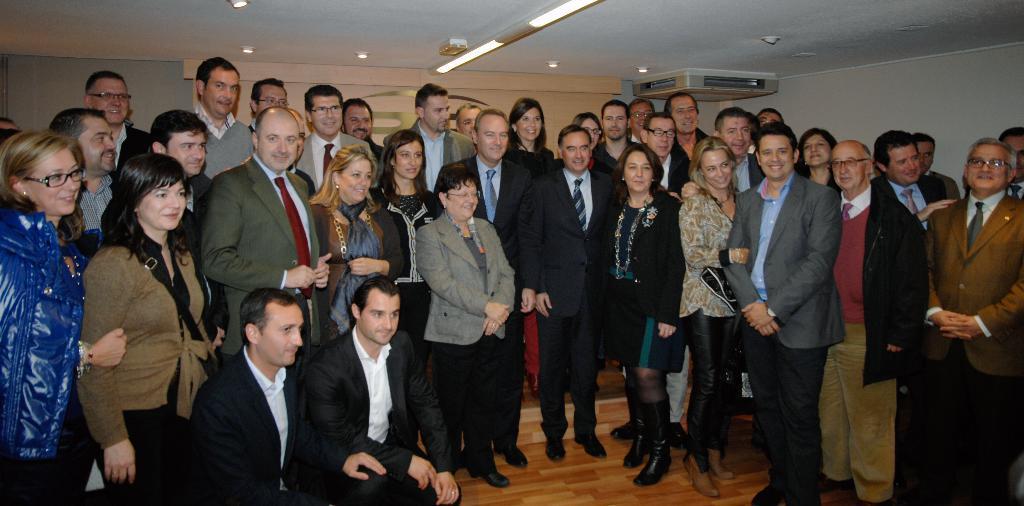How would you summarize this image in a sentence or two? In this picture we can see a group of people standing, smiling and two men on the floor and in the background we can see the lights, walls and some objects. 